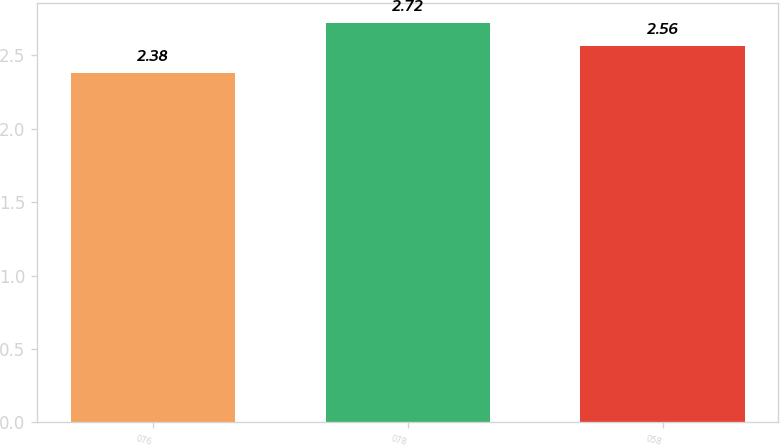<chart> <loc_0><loc_0><loc_500><loc_500><bar_chart><fcel>076<fcel>078<fcel>058<nl><fcel>2.38<fcel>2.72<fcel>2.56<nl></chart> 